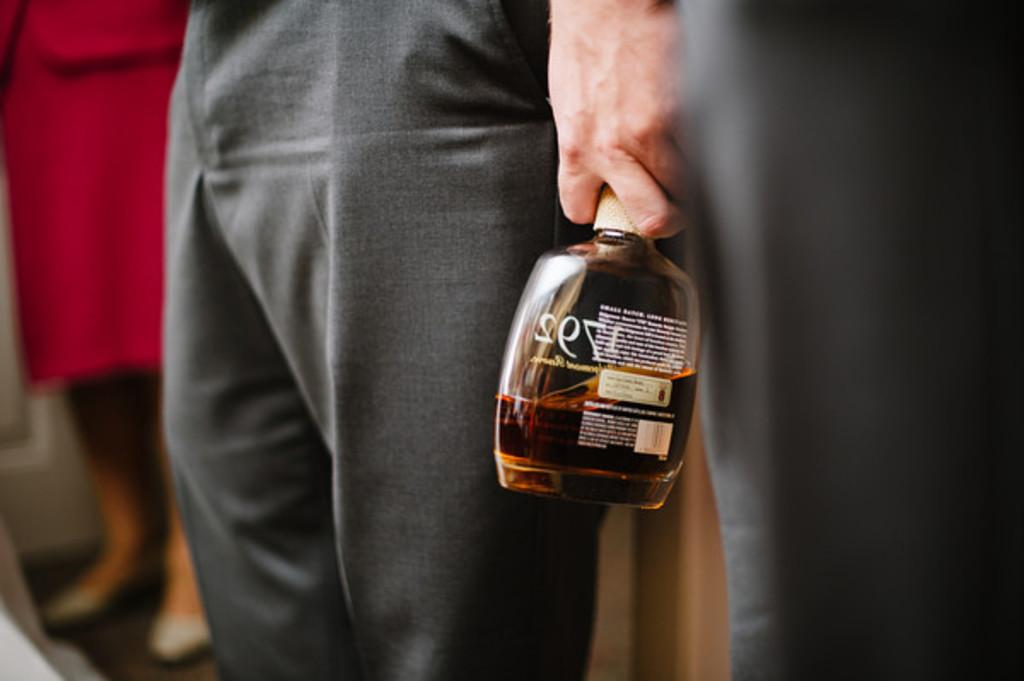How many people are present in the image? There are three people in the image. Can you describe the positioning of the people in the image? One person is in the center of the image. What is the person in the center holding? The person in the center is holding a bottle. What type of glove is the person on the side wearing in the image? There is no person on the side wearing a glove in the image. 